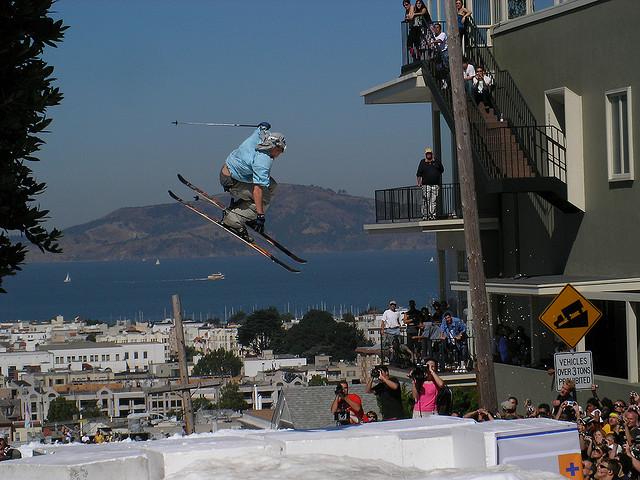Is this a museum?
Quick response, please. No. What is the man holding?
Short answer required. Ski poles. What activity is this man engaged in?
Be succinct. Skiing. What is he doing?
Keep it brief. Skiing. What color is the man's hat?
Be succinct. Gray. Do they do it this way in the Olympics?
Quick response, please. Yes. What is the guy jumping over?
Keep it brief. Wall. Which arm does the man have raised?
Quick response, please. Left. How many cameras are out?
Give a very brief answer. 5. What is the man in the background riding on?
Short answer required. Skis. What is the boy doing?
Keep it brief. Skiing. What color is his hat?
Quick response, please. Gray. Is this person in danger of hitting the wooden pole in front of him?
Quick response, please. Yes. What is providing shade?
Short answer required. Building. Are these people interested in the man's performance?
Keep it brief. Yes. Why wear head protection?
Answer briefly. Safety. Is this a marketplace?
Give a very brief answer. No. What is the ramp called?
Quick response, please. Snow ramp. What is below the man jumping?
Be succinct. Snow. What is in the man's hands?
Be succinct. Ski poles. What is this person holding?
Write a very short answer. Ski poles. Is this in a skate park?
Keep it brief. No. Is it raining?
Give a very brief answer. No. What color is the man's shirt?
Quick response, please. Blue. Is this man snowboarding?
Keep it brief. No. What kind of trees are in this photograph?
Write a very short answer. Oak. Why is that person in the air?
Quick response, please. Skiing. What is the man riding on the right?
Be succinct. Skis. What type of hat is the man wearing?
Short answer required. Baseball. What is this person riding?
Give a very brief answer. Skis. Who is on top of the rail?
Concise answer only. People. Is the person wearing a baseball cap or a helmet?
Quick response, please. Baseball cap. Why are people in the air?
Short answer required. Skiing. 